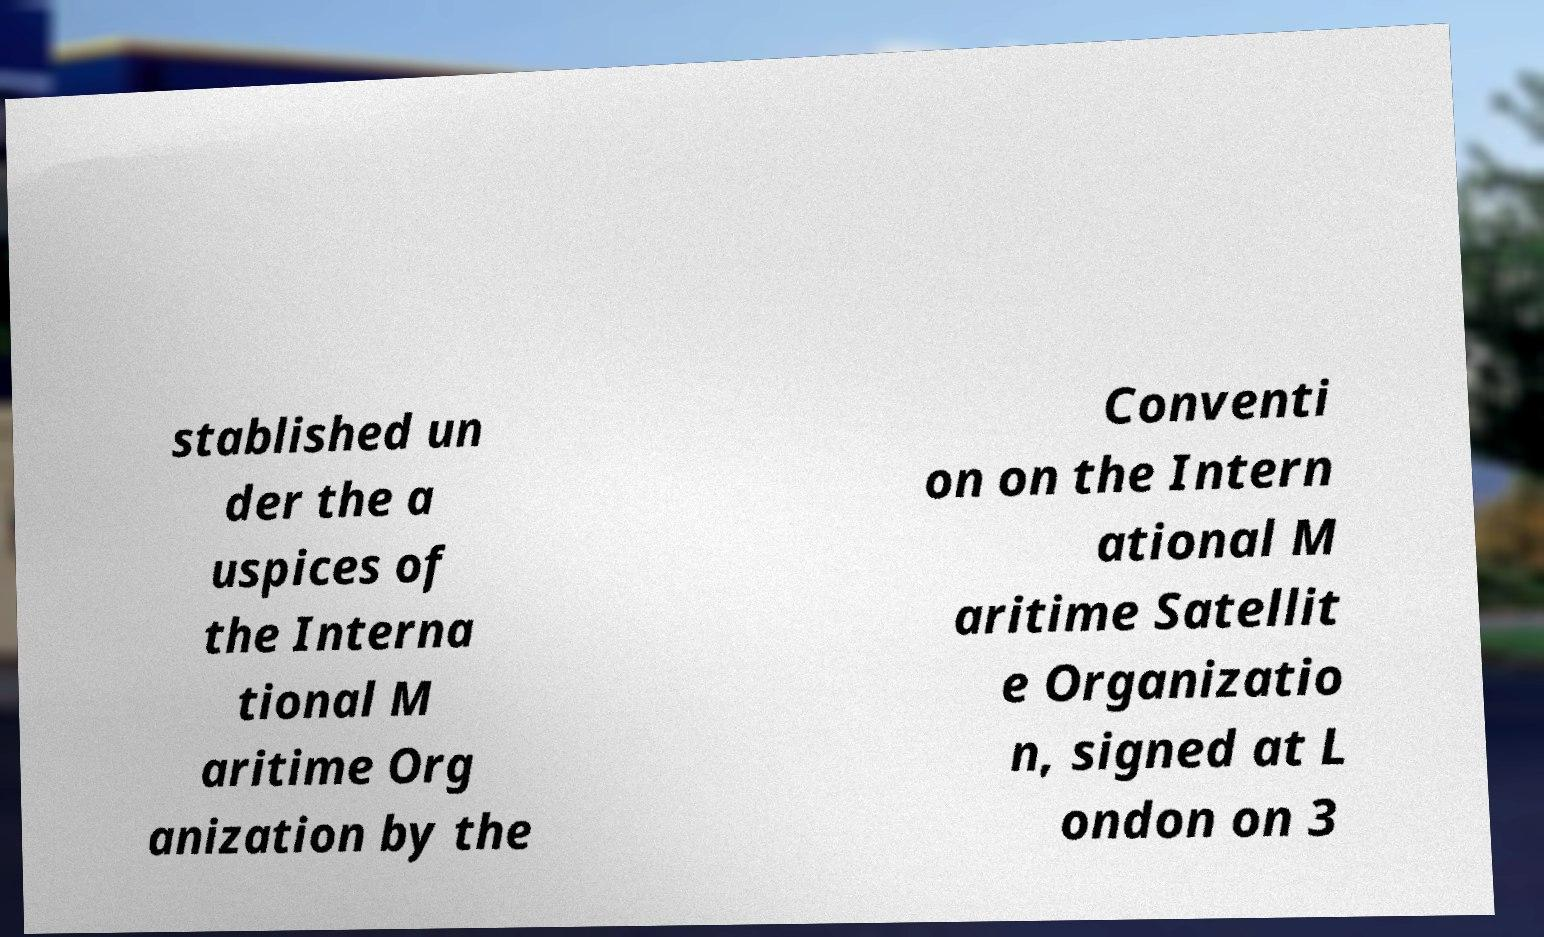For documentation purposes, I need the text within this image transcribed. Could you provide that? stablished un der the a uspices of the Interna tional M aritime Org anization by the Conventi on on the Intern ational M aritime Satellit e Organizatio n, signed at L ondon on 3 